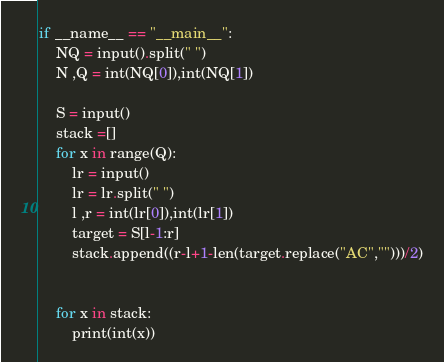Convert code to text. <code><loc_0><loc_0><loc_500><loc_500><_Python_>if __name__ == "__main__":
    NQ = input().split(" ")
    N ,Q = int(NQ[0]),int(NQ[1])

    S = input()
    stack =[]
    for x in range(Q):
        lr = input()
        lr = lr.split(" ")
        l ,r = int(lr[0]),int(lr[1])
        target = S[l-1:r]
        stack.append((r-l+1-len(target.replace("AC","")))/2)
        
        
    for x in stack:
        print(int(x))
</code> 